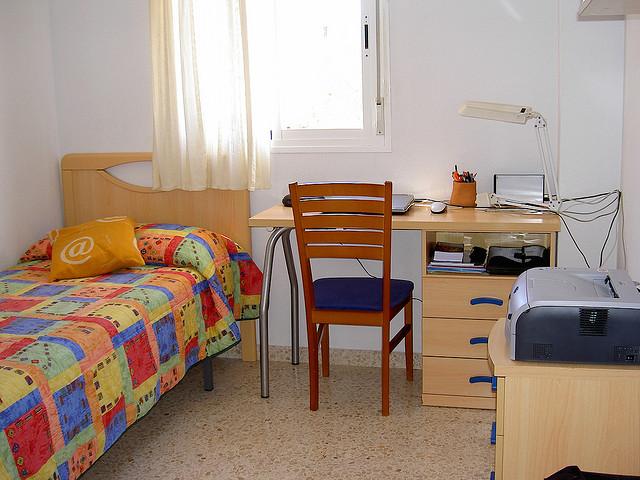For which member of the family might a room like this be acceptable?
Quick response, please. Child. What color is the seat cushion?
Short answer required. Blue. What color is the pillow on the bed?
Be succinct. Orange. 